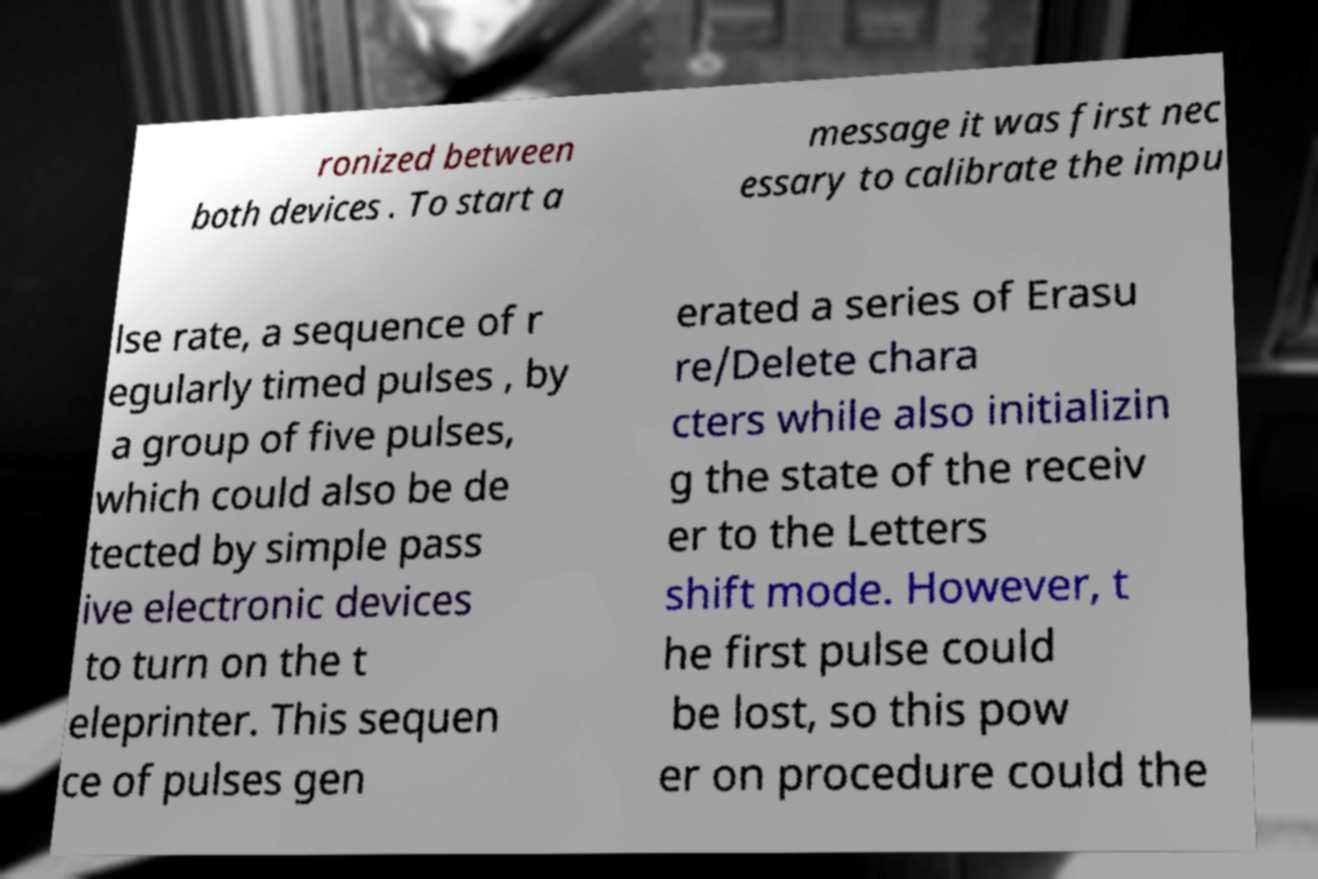What messages or text are displayed in this image? I need them in a readable, typed format. ronized between both devices . To start a message it was first nec essary to calibrate the impu lse rate, a sequence of r egularly timed pulses , by a group of five pulses, which could also be de tected by simple pass ive electronic devices to turn on the t eleprinter. This sequen ce of pulses gen erated a series of Erasu re/Delete chara cters while also initializin g the state of the receiv er to the Letters shift mode. However, t he first pulse could be lost, so this pow er on procedure could the 